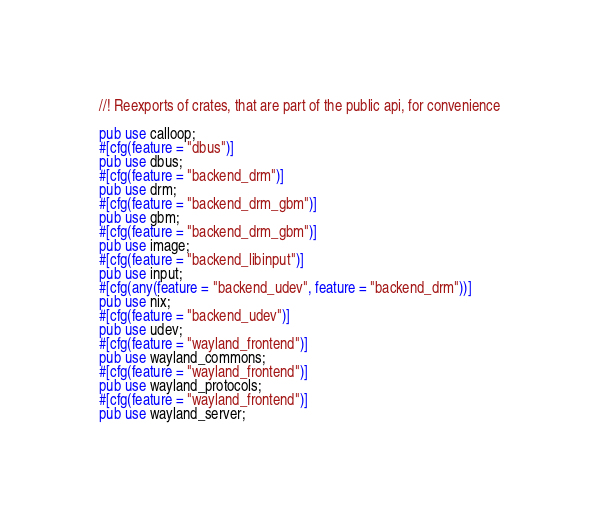Convert code to text. <code><loc_0><loc_0><loc_500><loc_500><_Rust_>//! Reexports of crates, that are part of the public api, for convenience

pub use calloop;
#[cfg(feature = "dbus")]
pub use dbus;
#[cfg(feature = "backend_drm")]
pub use drm;
#[cfg(feature = "backend_drm_gbm")]
pub use gbm;
#[cfg(feature = "backend_drm_gbm")]
pub use image;
#[cfg(feature = "backend_libinput")]
pub use input;
#[cfg(any(feature = "backend_udev", feature = "backend_drm"))]
pub use nix;
#[cfg(feature = "backend_udev")]
pub use udev;
#[cfg(feature = "wayland_frontend")]
pub use wayland_commons;
#[cfg(feature = "wayland_frontend")]
pub use wayland_protocols;
#[cfg(feature = "wayland_frontend")]
pub use wayland_server;
</code> 